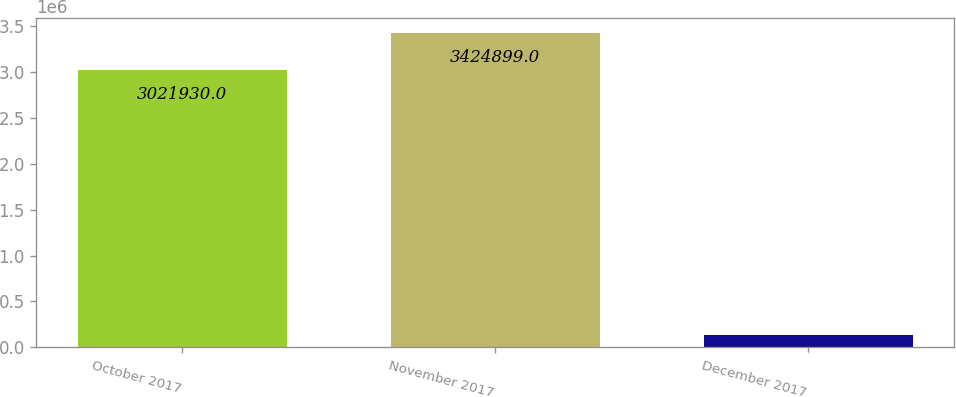Convert chart to OTSL. <chart><loc_0><loc_0><loc_500><loc_500><bar_chart><fcel>October 2017<fcel>November 2017<fcel>December 2017<nl><fcel>3.02193e+06<fcel>3.4249e+06<fcel>128943<nl></chart> 